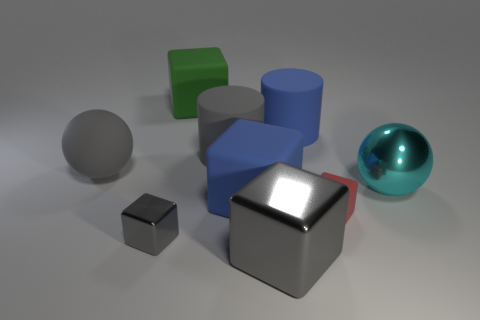Is the number of green matte cubes less than the number of large yellow cylinders?
Give a very brief answer. No. There is a large blue rubber thing that is right of the large cube in front of the blue block; is there a big blue cube in front of it?
Provide a short and direct response. Yes. What number of metal objects are either green cubes or small red cubes?
Your answer should be compact. 0. Does the small rubber cube have the same color as the rubber sphere?
Your answer should be compact. No. There is a big green cube; how many large rubber cylinders are on the right side of it?
Your answer should be very brief. 2. What number of gray objects are behind the small gray metal object and to the left of the green object?
Your answer should be compact. 1. What is the shape of the tiny object that is made of the same material as the big cyan thing?
Provide a short and direct response. Cube. Does the matte cylinder on the left side of the large blue cube have the same size as the gray matte thing that is left of the green matte object?
Provide a short and direct response. Yes. There is a large matte cylinder that is in front of the blue matte cylinder; what color is it?
Your response must be concise. Gray. There is a gray thing that is behind the large ball on the left side of the small matte object; what is it made of?
Your answer should be very brief. Rubber. 